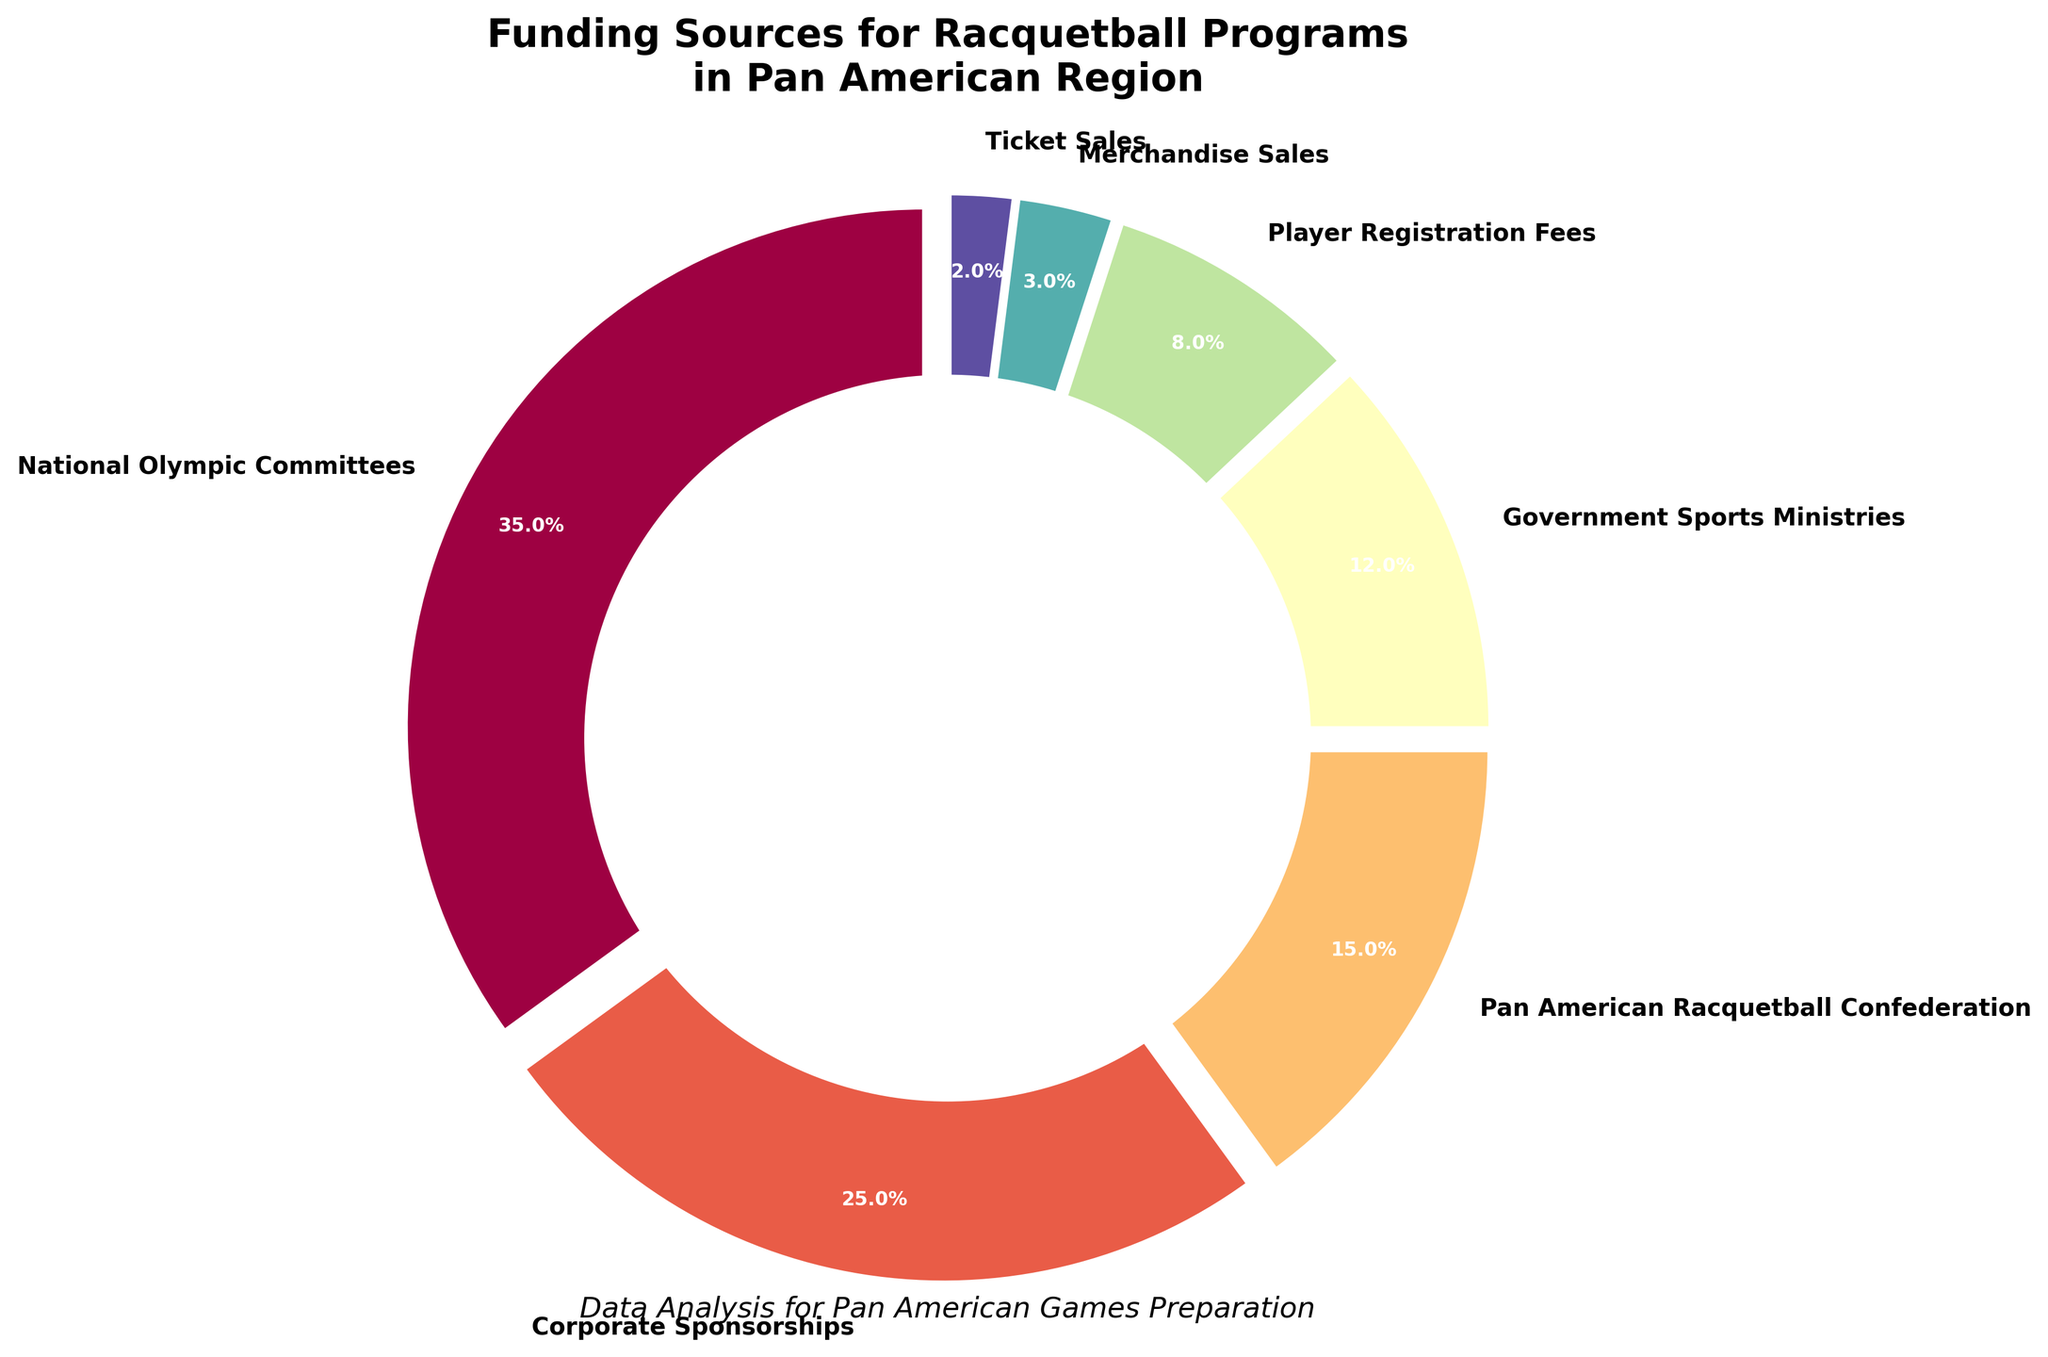What's the largest funding source for racquetball programs in the Pan American region? The largest segment by percentage is 35%, which corresponds to National Olympic Committees
Answer: National Olympic Committees What percentage of funding comes from Player Registration Fees and Merchandise Sales combined? Player Registration Fees contribute 8% and Merchandise Sales contribute 3%. Summing them up, 8% + 3% equals 11%
Answer: 11% Which funding source has a smaller percentage, Government Sports Ministries or Pan American Racquetball Confederation? Comparing the percentages, Government Sports Ministries contribute 12% while Pan American Racquetball Confederation contributes 15%. 12% is smaller than 15%
Answer: Government Sports Ministries What's the difference in percentage points between Corporate Sponsorships and Ticket Sales? Corporate Sponsorships contribute 25% while Ticket Sales contribute 2%. The difference is 25% - 2% equaling 23%
Answer: 23% How many funding sources contribute less than 10% each? Funding sources with percentages below 10% are Player Registration Fees, Merchandise Sales, and Ticket Sales. Counting them, 3 funding sources contribute less than 10% each
Answer: 3 Which segment is represented by the lightest color in the pie chart? The lightest color typically represents the smallest percentage, which is Ticket Sales at 2%
Answer: Ticket Sales Are Corporate Sponsorships and Government Sports Ministries combined larger than National Olympic Committees? Corporate Sponsorships contribute 25% and Government Sports Ministries contribute 12%. Summing them, 25% + 12% equals 37%. National Olympic Committees contribute 35%, so 37% is larger than 35%
Answer: Yes If we add the percentages of National Olympic Committees and Pan American Racquetball Confederation, what is the total percentage? National Olympic Committees contribute 35% and Pan American Racquetball Confederation contributes 15%. Summing them, 35% + 15% equals 50%
Answer: 50% What percentage is shared between Merchandise Sales and Ticket Sales? Merchandise Sales contribute 3% and Ticket Sales contribute 2%. Summing them, 3% + 2% equals 5%
Answer: 5% Which funding sources have higher percentages than Player Registration Fees? Funding sources with percentages higher than Player Registration Fees (8%) are National Olympic Committees (35%), Corporate Sponsorships (25%), and Pan American Racquetball Confederation (15%)
Answer: National Olympic Committees, Corporate Sponsorships, Pan American Racquetball Confederation 